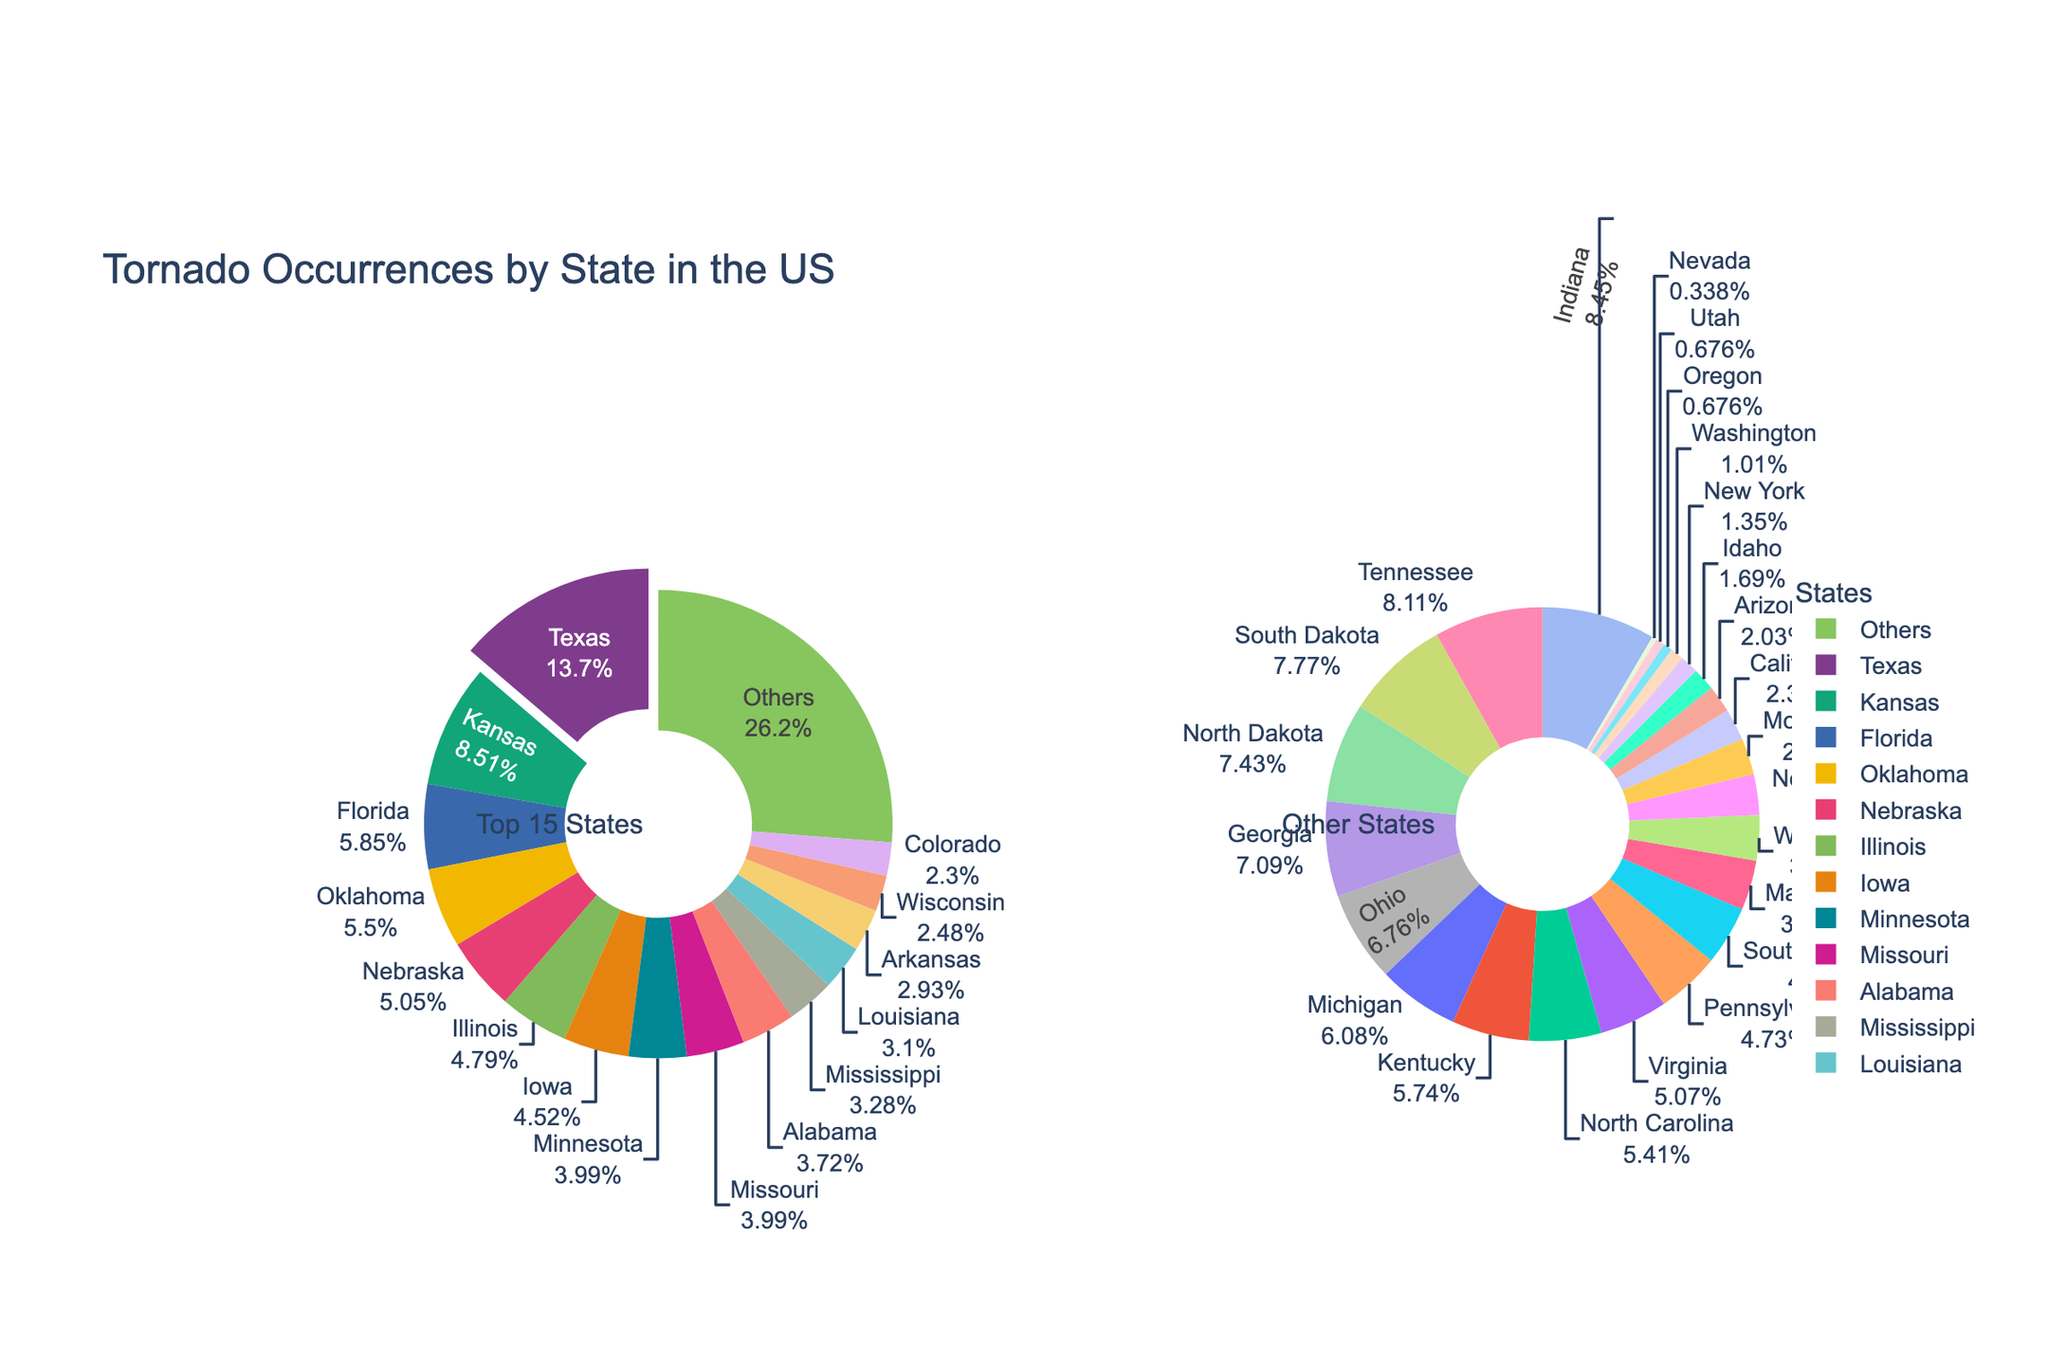What's the total number of tornado occurrences in the top 15 states? Sum the tornado occurrences of the top 15 states: 155 (Texas) + 96 (Kansas) + 66 (Florida) + 62 (Oklahoma) + 57 (Nebraska) + 54 (Illinois) + 51 (Iowa) + 45 (Minnesota) + 45 (Missouri) + 42 (Alabama) + 37 (Mississippi) + 35 (Louisiana) + 33 (Arkansas) + 28 (Wisconsin) + 26 (Colorado) = 832
Answer: 832 Which state has the highest percentage of tornado occurrences? Texas has the highest percentage in the pie chart segment that is pulled out and labeled with the highest percentage.
Answer: Texas What is the combined percentage of tornado occurrences for Kansas and Florida? Identify the percentages labeled for Kansas and Florida, and sum them: Kansas (approximately 11.5%) + Florida (approximately 7.9%) ≈ 19.4%
Answer: 19.4 How does the number of tornado occurrences in Oklahoma compare to that in Nebraska? Both segments are labeled with their respective tornado occurrences: Oklahoma has 62, while Nebraska has 57. Oklahoma has more tornado occurrences.
Answer: Oklahoma has more Which states are represented by the smallest segments in the "Others" pie chart? The smallest segments in the "Others" pie chart are visible at the bottom of the chart, which appear to be Nevada and Utah, each with 1 and 2 tornado occurrences respectively.
Answer: Nevada and Utah What's the total percentage of tornado occurrences in the 'Others' pie chart? The 'Others' pie chart represents the combined total percentage for the states not in the top 15. Looking at the pie chart, this total percentage should be approximately represented by the "Others" segment in the main pie chart, roughly equivalent to the difference between 100% and the sum of percentages of the top 15 states.
Answer: Approximately 12% What percentage of tornado occurrences do Texas and Kansas contribute together? Identify the percentages for Texas and Kansas from the main pie chart and sum them: Texas (approximately 18.6%) + Kansas (approximately 11.5%) ≈ 30.1%
Answer: 30.1 How many states have fewer tornado occurrences than Georgia? Georgia has 21 tornado occurrences. Count the states with fewer occurrences: Virginia (15), Pennsylvania (14), South Carolina (13), Maryland (11), Wyoming (10), New Mexico (9), Montana (8), California (7), Arizona (6), Idaho (5), New York (4), Washington (3), Oregon (2), Utah (2), Nevada (1) totaling 15 states.
Answer: 15 What's the total count of tornado occurrences for the states in the "Others" pie chart? Sum the tornado occurrences for the states outside the top 15: (24 + 23 + 22 + 21 + 20 + 18 + 17 + 16 + 15 + 14 + 13 + 11 + 10 + 9 + 8 + 7 + 6 + 5 + 4 + 3 + 2 + 2 + 1) = 299
Answer: 299 What is the percentage difference between tornado occurrences in Iowa and Louisiana? Identify the percentages for Iowa (45 occurrences) and Louisiana (35 occurrences) from the pie chart. Approximate their percentages and compare: Iowa (approximately 5.4%) - Louisiana (approximately 4.2%) ≈ 1.2%
Answer: 1.2% 